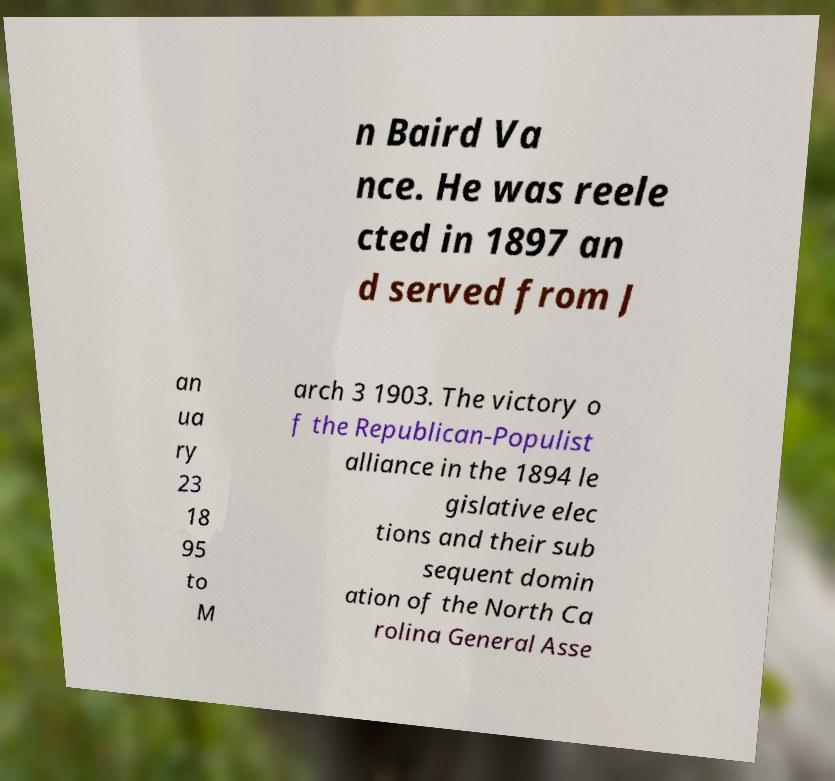For documentation purposes, I need the text within this image transcribed. Could you provide that? n Baird Va nce. He was reele cted in 1897 an d served from J an ua ry 23 18 95 to M arch 3 1903. The victory o f the Republican-Populist alliance in the 1894 le gislative elec tions and their sub sequent domin ation of the North Ca rolina General Asse 